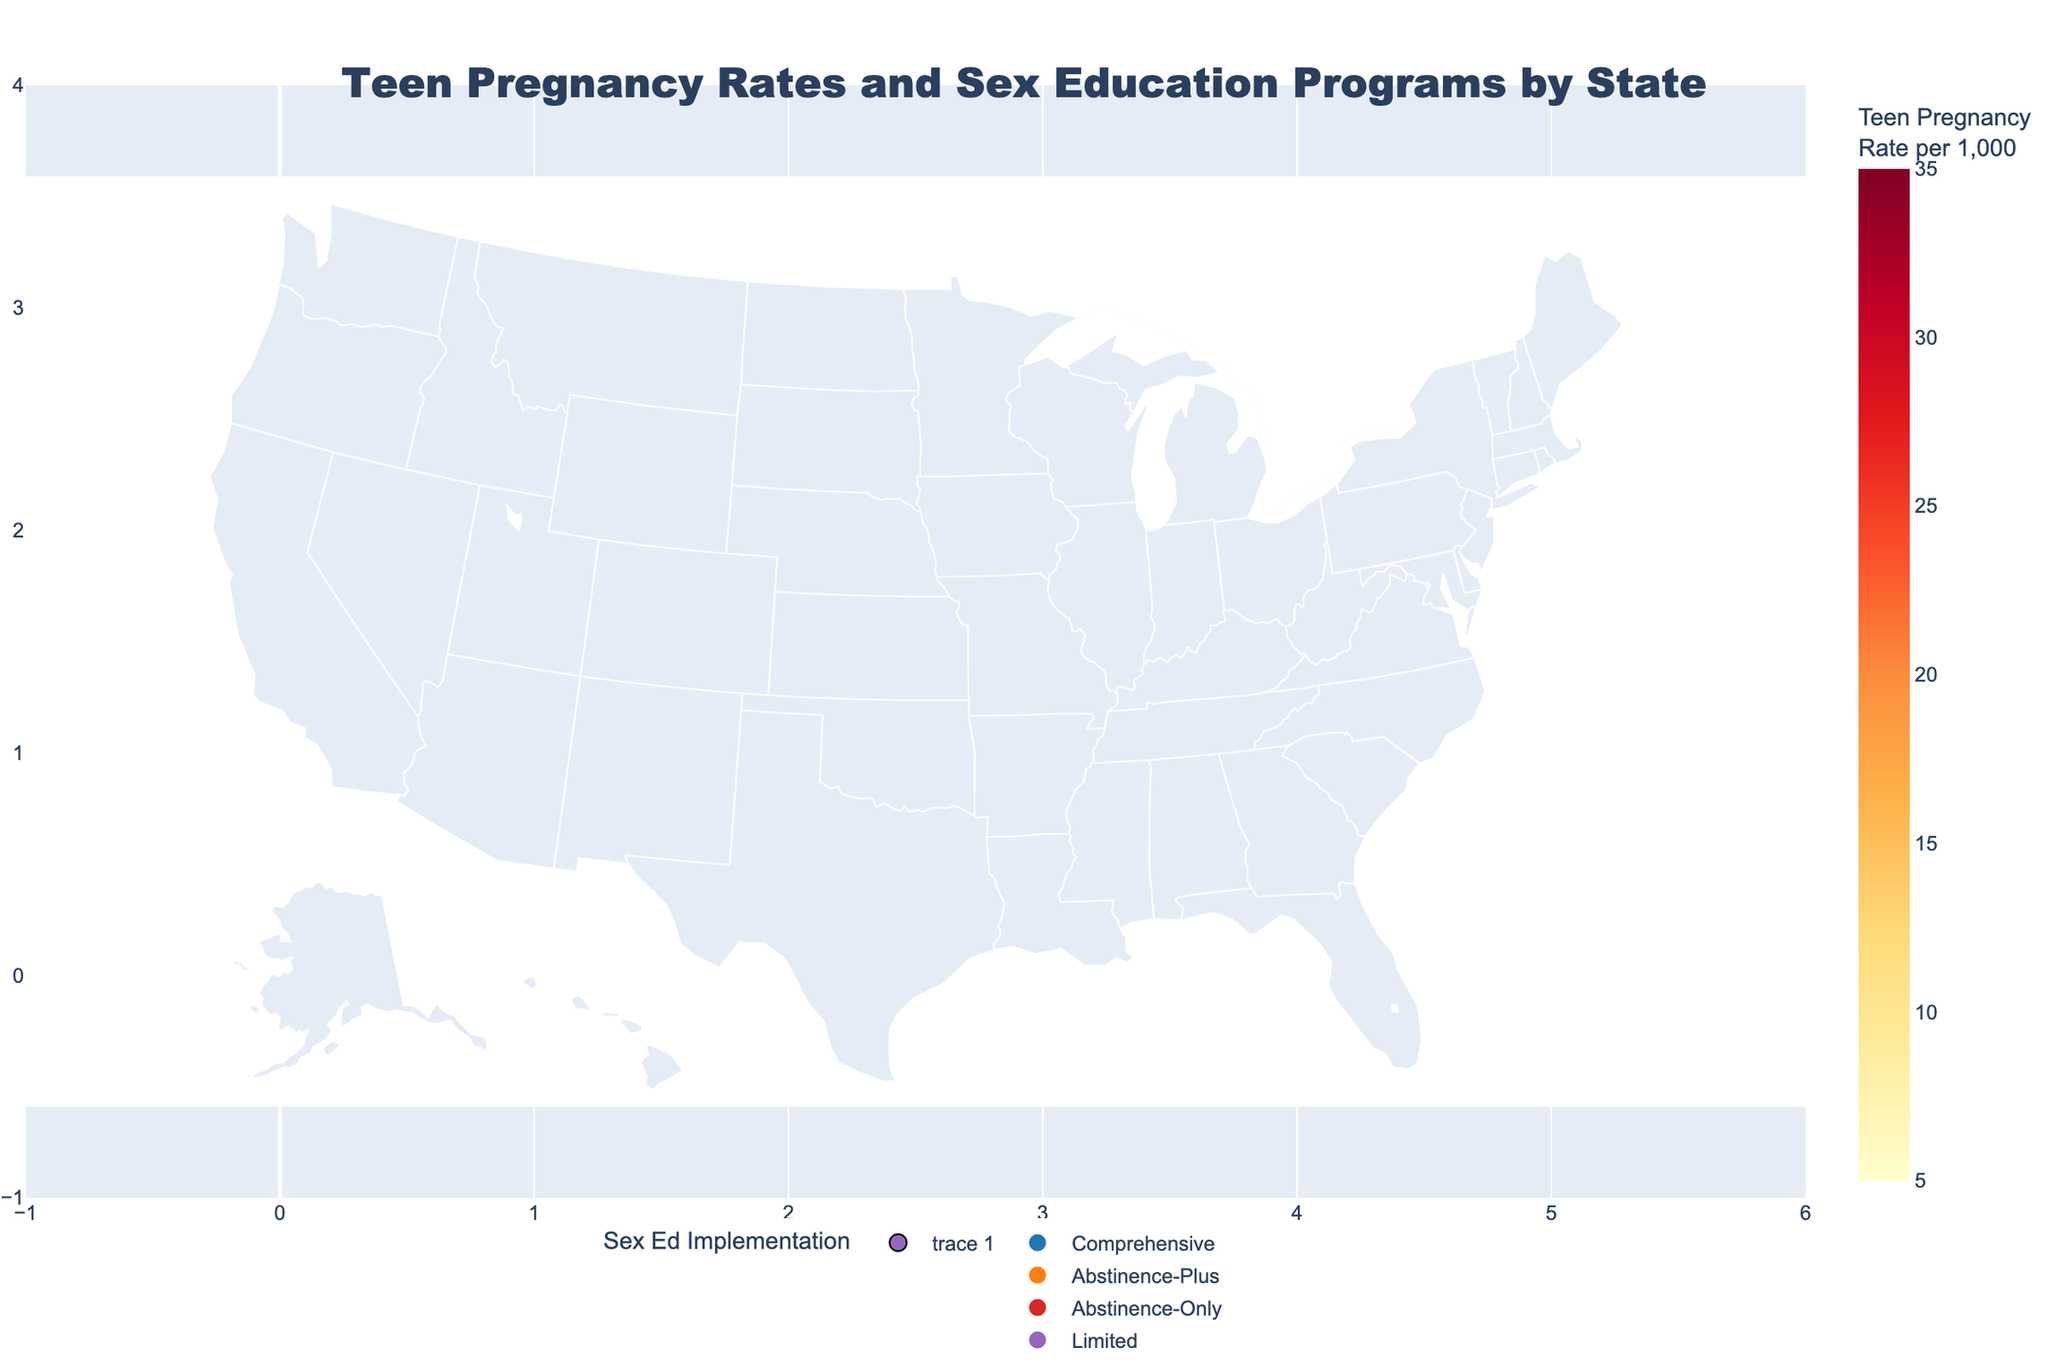What's the highest teen pregnancy rate shown on the map? Locate the state with the highest value in the "Teen Pregnancy Rate" color scale. Mississippi has the darkest shade, indicating a rate of 30.1.
Answer: 30.1 Which states have implemented comprehensive sex education programs? Look for markers that are blue, as the color blue represents comprehensive sex education programs according to the color map. The relevant states are New Mexico, South Carolina, North Carolina, Ohio, Delaware, Virginia, New York, California, and Massachusetts.
Answer: New Mexico, South Carolina, North Carolina, Ohio, Delaware, Virginia, New York, California, Massachusetts What is the teen pregnancy rate in California, and what type of sex education program do they have? Find California on the map and hover over it to see the teen pregnancy rate and the type of sex education program. California has a pregnancy rate of 11.9 and a comprehensive sex education program.
Answer: 11.9, Comprehensive Is there any correlation between states with abstinence-only programs and their teen pregnancy rates? Check the map for states colored red (abstinence-only) and note their corresponding teen pregnancy rates. States like Arkansas (27.8), Louisiana (25.7), and Texas (22.4) have higher rates compared to other states with comprehensive programs.
Answer: Higher rates generally Which state has the lowest teen pregnancy rate, and what type of sex education program do they implement? Look for the state with the lightest shade on the color scale and check its information. Massachusetts has the lowest rate (7.2) and implements comprehensive sex education.
Answer: Massachusetts, Comprehensive How do the teen pregnancy rates in states with abstinence-plus programs compare to those with comprehensive programs? Compare the average rates of states with abstinence-plus (orange markers) and those with comprehensive (blue markers). Abstinence-plus states have varied rates with several above 20, while comprehensive states generally have lower rates, with many below 20.
Answer: Abstinence-plus generally higher Are there any states with limited sex education implementation, and what are their teen pregnancy rates? Identify states marked with purple markers representing limited sex education. Mississippi is the only state with limited implementation, and it has a teen pregnancy rate of 30.1.
Answer: Mississippi, 30.1 Which region of the United States has higher teen pregnancy rates, and what type of sex education program is more common there? Compare regions by grouping states geographically and noting their teen pregnancy rates and sex education types. The southeastern region has relatively higher teen pregnancy rates and commonly implements abstinence-only or abstinence-plus programs.
Answer: Southeastern, Abstinence-Only/Plus 